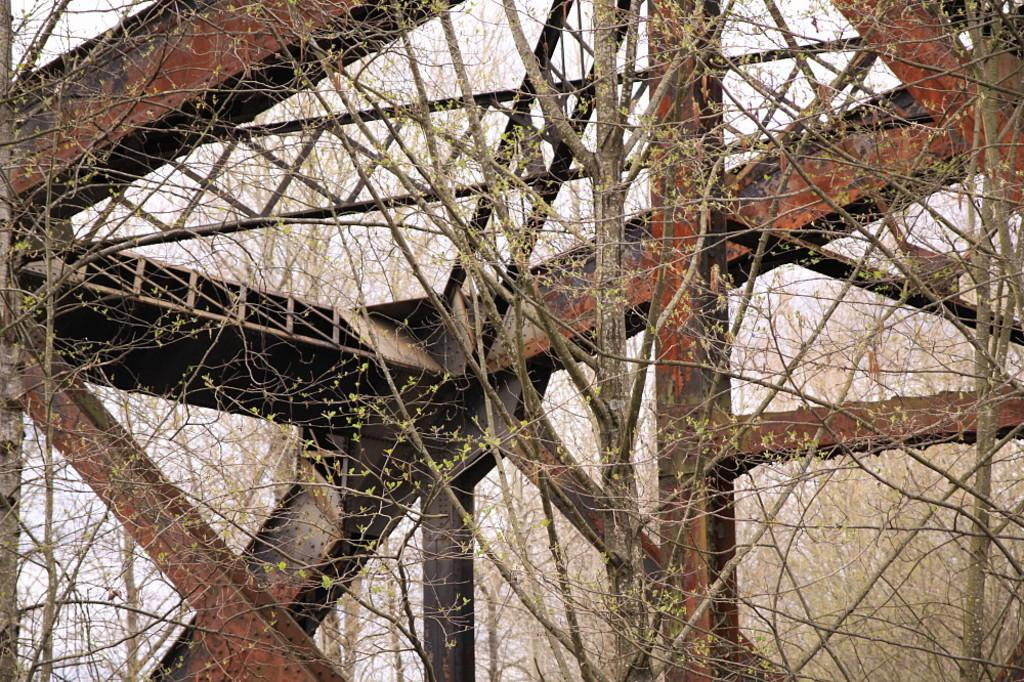Where was the image taken? The image is taken outdoors. What can be seen in the image that might be associated with a structure or barrier? There are iron bars in the image. What type of vegetation is present in the image? There are trees with stems, branches, and leaves in the image. What is visible at the top of the image? The sky is visible at the top of the image. What type of lace can be seen on the sidewalk in the image? There is no lace present on the sidewalk in the image. What activity is taking place in the image? The image does not depict any specific activity; it primarily features trees, iron bars, and the sky. 